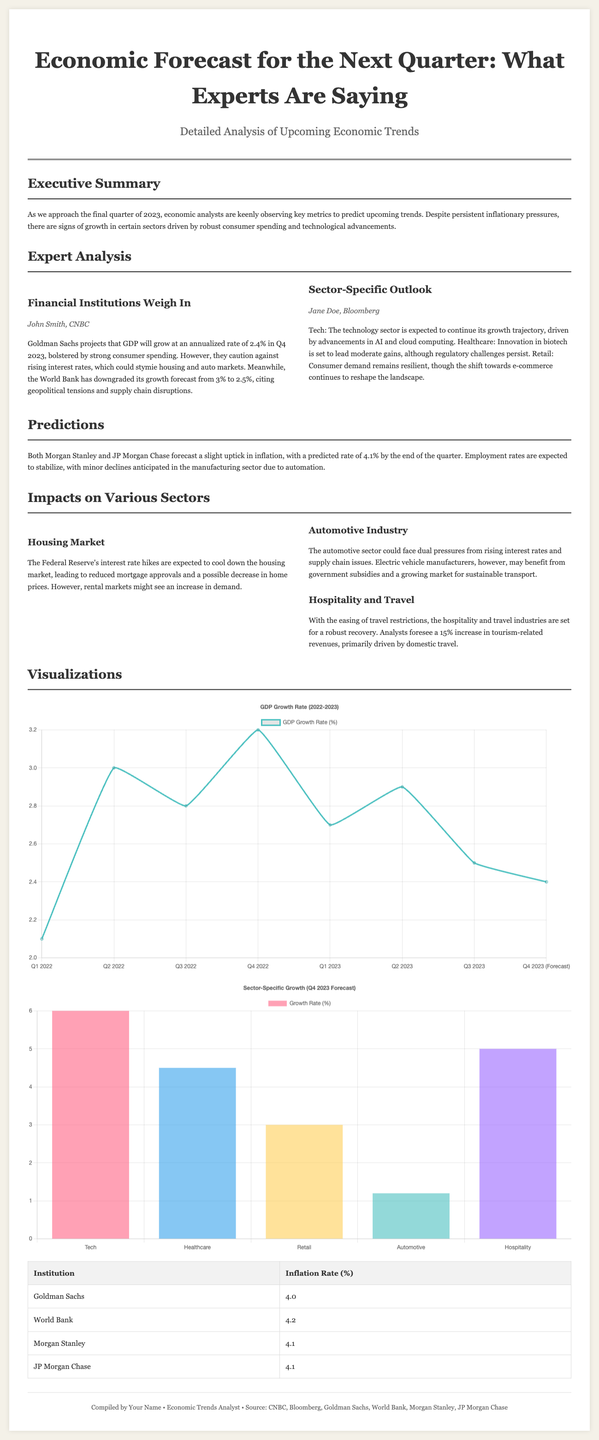What is the GDP growth rate forecast for Q4 2023? The forecasted GDP growth rate for Q4 2023 is 2.4%, as projected by Goldman Sachs.
Answer: 2.4% What is the projected inflation rate by the end of the quarter? The inflation rate is predicted to be 4.1% by the end of the quarter according to both Morgan Stanley and JP Morgan Chase.
Answer: 4.1% Which financial institution downgraded its growth forecast from 3% to 2.5%? The World Bank downgraded its growth forecast from 3% to 2.5% due to geopolitical tensions and supply chain disruptions.
Answer: World Bank What is the expected increase in tourism-related revenues in the hospitality and travel sector? Analysts foresee a 15% increase in tourism-related revenues primarily driven by domestic travel.
Answer: 15% What sector is expected to benefit from advancements in AI and cloud computing? The technology sector is expected to continue its growth trajectory due to advancements in AI and cloud computing.
Answer: Technology How many institutions are listed in the inflation rate table? The table lists four institutions along with their respective inflation rate predictions.
Answer: Four What color corresponds to the automotive industry in the sector-specific growth chart? The color for the automotive industry in the sector-specific growth chart is light blue (rgb(75, 192, 192)).
Answer: Light blue What is the primary factor affecting the housing market according to the document? The Federal Reserve's interest rate hikes are primarily affecting the housing market.
Answer: Interest rate hikes What type of article format is used in the Economic Forecast layout? The article is written in a two-column format for better readability and organization.
Answer: Two-column format 